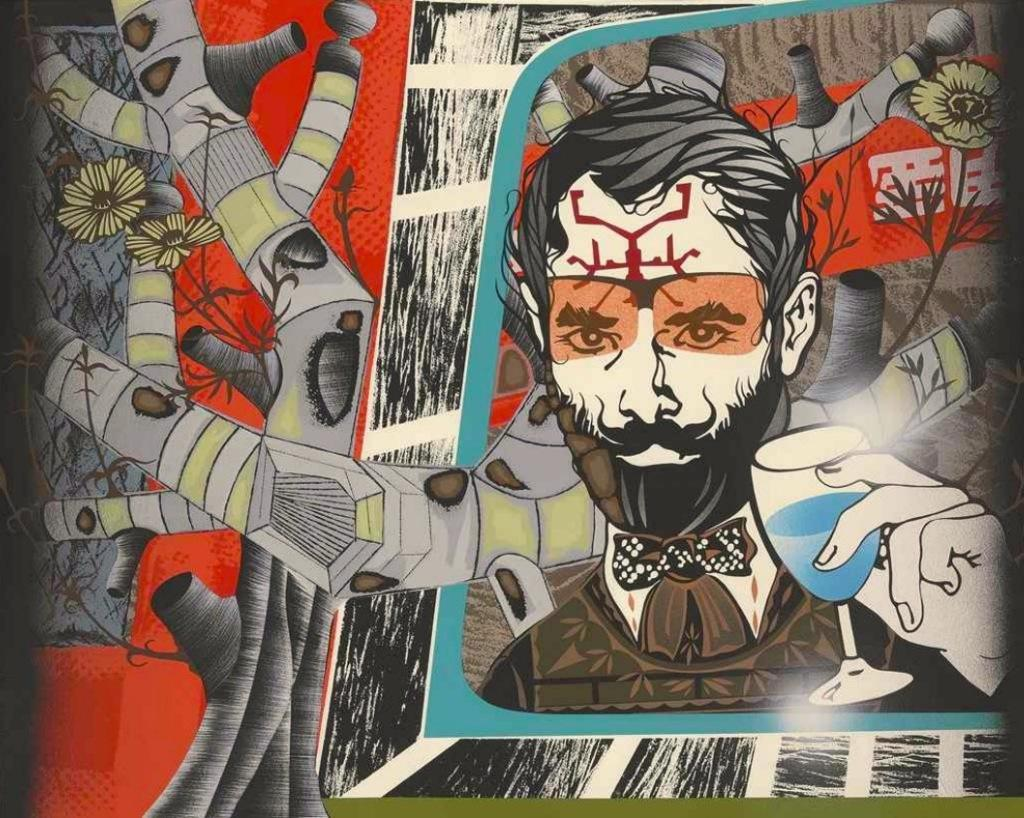What type of image is being depicted? The image is an animated picture. Can you describe the main subject in the image? There is a man in the image. Where is the man located in the image? The man is on the right side of the image. What is the man holding in the image? The man is holding a wine glass. What type of bubble can be seen floating around the man in the image? There is no bubble present in the image. What type of game is the man playing in the image? There is no game being played in the image. 